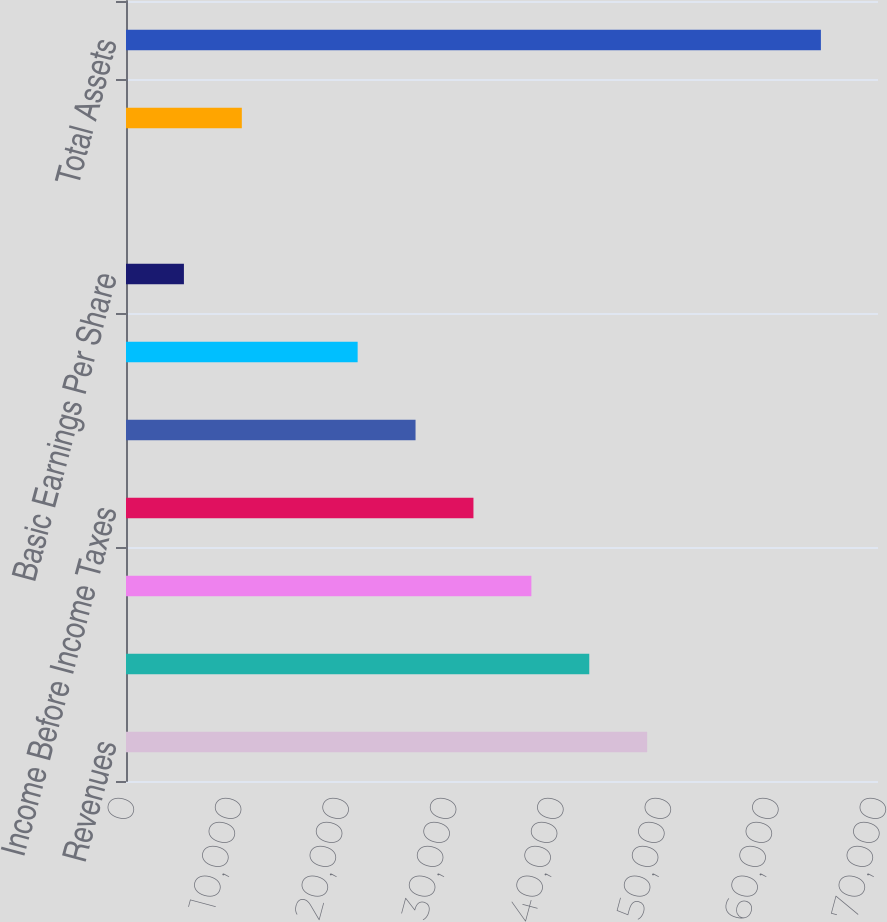<chart> <loc_0><loc_0><loc_500><loc_500><bar_chart><fcel>Revenues<fcel>Gross Profit (a)<fcel>Operating Income (a)<fcel>Income Before Income Taxes<fcel>Income Tax (Benefit) Provision<fcel>Net Income<fcel>Basic Earnings Per Share<fcel>Diluted Earnings Per Share<fcel>Dividends Per Common Share<fcel>Total Assets<nl><fcel>48513.7<fcel>43123.3<fcel>37733<fcel>32342.6<fcel>26952.3<fcel>21562<fcel>5390.94<fcel>0.6<fcel>10781.3<fcel>64684.7<nl></chart> 